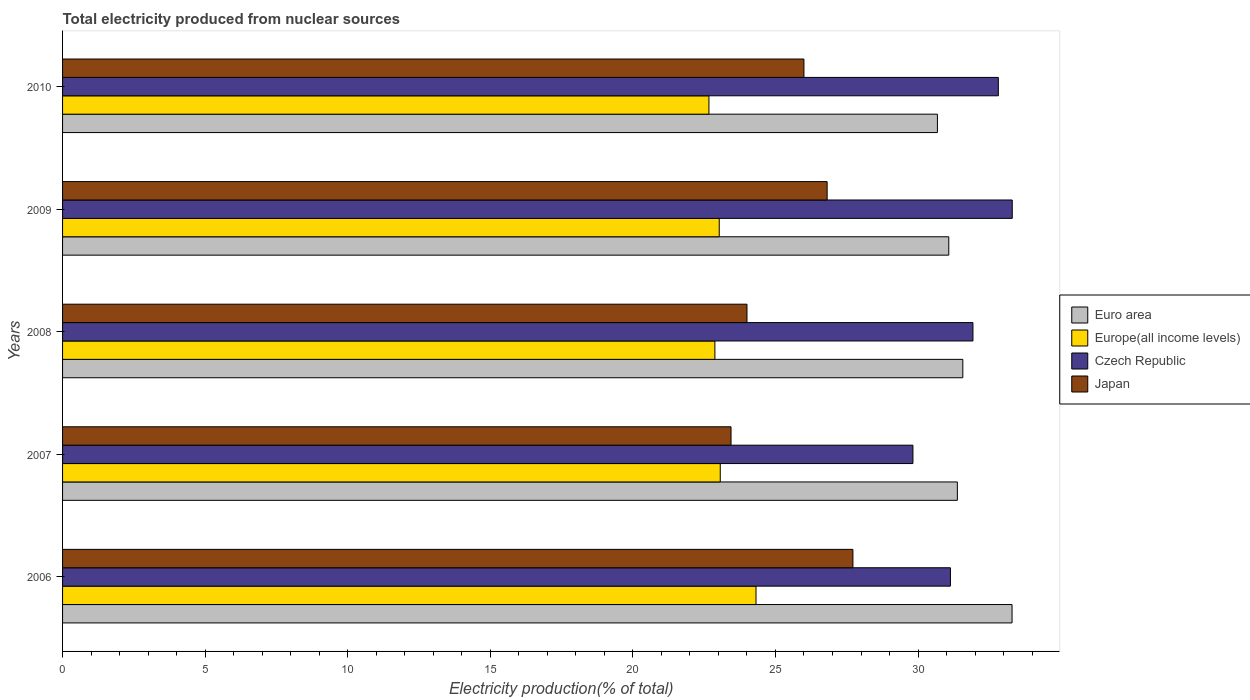Are the number of bars on each tick of the Y-axis equal?
Your answer should be compact. Yes. How many bars are there on the 4th tick from the bottom?
Provide a succinct answer. 4. In how many cases, is the number of bars for a given year not equal to the number of legend labels?
Your answer should be compact. 0. What is the total electricity produced in Europe(all income levels) in 2010?
Make the answer very short. 22.67. Across all years, what is the maximum total electricity produced in Europe(all income levels)?
Ensure brevity in your answer.  24.32. Across all years, what is the minimum total electricity produced in Euro area?
Offer a very short reply. 30.68. In which year was the total electricity produced in Europe(all income levels) maximum?
Provide a succinct answer. 2006. In which year was the total electricity produced in Europe(all income levels) minimum?
Offer a terse response. 2010. What is the total total electricity produced in Euro area in the graph?
Provide a short and direct response. 158. What is the difference between the total electricity produced in Euro area in 2007 and that in 2008?
Make the answer very short. -0.19. What is the difference between the total electricity produced in Japan in 2009 and the total electricity produced in Euro area in 2008?
Ensure brevity in your answer.  -4.76. What is the average total electricity produced in Euro area per year?
Ensure brevity in your answer.  31.6. In the year 2008, what is the difference between the total electricity produced in Europe(all income levels) and total electricity produced in Czech Republic?
Offer a very short reply. -9.05. In how many years, is the total electricity produced in Europe(all income levels) greater than 30 %?
Give a very brief answer. 0. What is the ratio of the total electricity produced in Europe(all income levels) in 2006 to that in 2010?
Your answer should be very brief. 1.07. Is the total electricity produced in Europe(all income levels) in 2007 less than that in 2009?
Provide a short and direct response. No. What is the difference between the highest and the second highest total electricity produced in Czech Republic?
Offer a terse response. 0.49. What is the difference between the highest and the lowest total electricity produced in Japan?
Provide a short and direct response. 4.27. Is the sum of the total electricity produced in Euro area in 2008 and 2009 greater than the maximum total electricity produced in Europe(all income levels) across all years?
Ensure brevity in your answer.  Yes. Is it the case that in every year, the sum of the total electricity produced in Czech Republic and total electricity produced in Japan is greater than the sum of total electricity produced in Europe(all income levels) and total electricity produced in Euro area?
Your answer should be very brief. No. What does the 2nd bar from the top in 2008 represents?
Offer a very short reply. Czech Republic. How many bars are there?
Your response must be concise. 20. Are all the bars in the graph horizontal?
Ensure brevity in your answer.  Yes. How many years are there in the graph?
Your response must be concise. 5. Does the graph contain any zero values?
Your answer should be compact. No. Does the graph contain grids?
Make the answer very short. No. Where does the legend appear in the graph?
Keep it short and to the point. Center right. What is the title of the graph?
Provide a short and direct response. Total electricity produced from nuclear sources. Does "South Asia" appear as one of the legend labels in the graph?
Provide a succinct answer. No. What is the label or title of the Y-axis?
Your answer should be compact. Years. What is the Electricity production(% of total) in Euro area in 2006?
Your answer should be very brief. 33.3. What is the Electricity production(% of total) of Europe(all income levels) in 2006?
Offer a very short reply. 24.32. What is the Electricity production(% of total) of Czech Republic in 2006?
Your answer should be compact. 31.14. What is the Electricity production(% of total) in Japan in 2006?
Your answer should be compact. 27.72. What is the Electricity production(% of total) of Euro area in 2007?
Provide a short and direct response. 31.38. What is the Electricity production(% of total) of Europe(all income levels) in 2007?
Offer a terse response. 23.06. What is the Electricity production(% of total) of Czech Republic in 2007?
Give a very brief answer. 29.82. What is the Electricity production(% of total) of Japan in 2007?
Make the answer very short. 23.44. What is the Electricity production(% of total) of Euro area in 2008?
Make the answer very short. 31.57. What is the Electricity production(% of total) in Europe(all income levels) in 2008?
Keep it short and to the point. 22.88. What is the Electricity production(% of total) in Czech Republic in 2008?
Offer a terse response. 31.93. What is the Electricity production(% of total) in Japan in 2008?
Provide a succinct answer. 24. What is the Electricity production(% of total) in Euro area in 2009?
Offer a terse response. 31.08. What is the Electricity production(% of total) of Europe(all income levels) in 2009?
Ensure brevity in your answer.  23.03. What is the Electricity production(% of total) of Czech Republic in 2009?
Keep it short and to the point. 33.3. What is the Electricity production(% of total) of Japan in 2009?
Provide a short and direct response. 26.81. What is the Electricity production(% of total) in Euro area in 2010?
Provide a short and direct response. 30.68. What is the Electricity production(% of total) of Europe(all income levels) in 2010?
Make the answer very short. 22.67. What is the Electricity production(% of total) of Czech Republic in 2010?
Keep it short and to the point. 32.82. What is the Electricity production(% of total) in Japan in 2010?
Make the answer very short. 26. Across all years, what is the maximum Electricity production(% of total) of Euro area?
Keep it short and to the point. 33.3. Across all years, what is the maximum Electricity production(% of total) in Europe(all income levels)?
Provide a succinct answer. 24.32. Across all years, what is the maximum Electricity production(% of total) in Czech Republic?
Offer a very short reply. 33.3. Across all years, what is the maximum Electricity production(% of total) in Japan?
Ensure brevity in your answer.  27.72. Across all years, what is the minimum Electricity production(% of total) of Euro area?
Provide a short and direct response. 30.68. Across all years, what is the minimum Electricity production(% of total) in Europe(all income levels)?
Your response must be concise. 22.67. Across all years, what is the minimum Electricity production(% of total) of Czech Republic?
Make the answer very short. 29.82. Across all years, what is the minimum Electricity production(% of total) of Japan?
Keep it short and to the point. 23.44. What is the total Electricity production(% of total) of Euro area in the graph?
Your answer should be compact. 158. What is the total Electricity production(% of total) of Europe(all income levels) in the graph?
Offer a terse response. 115.95. What is the total Electricity production(% of total) of Czech Republic in the graph?
Make the answer very short. 159. What is the total Electricity production(% of total) of Japan in the graph?
Offer a very short reply. 127.97. What is the difference between the Electricity production(% of total) of Euro area in 2006 and that in 2007?
Ensure brevity in your answer.  1.92. What is the difference between the Electricity production(% of total) of Europe(all income levels) in 2006 and that in 2007?
Keep it short and to the point. 1.25. What is the difference between the Electricity production(% of total) of Czech Republic in 2006 and that in 2007?
Give a very brief answer. 1.31. What is the difference between the Electricity production(% of total) of Japan in 2006 and that in 2007?
Make the answer very short. 4.27. What is the difference between the Electricity production(% of total) in Euro area in 2006 and that in 2008?
Give a very brief answer. 1.73. What is the difference between the Electricity production(% of total) in Europe(all income levels) in 2006 and that in 2008?
Your answer should be compact. 1.44. What is the difference between the Electricity production(% of total) in Czech Republic in 2006 and that in 2008?
Make the answer very short. -0.79. What is the difference between the Electricity production(% of total) of Japan in 2006 and that in 2008?
Your answer should be very brief. 3.71. What is the difference between the Electricity production(% of total) of Euro area in 2006 and that in 2009?
Your answer should be compact. 2.22. What is the difference between the Electricity production(% of total) in Europe(all income levels) in 2006 and that in 2009?
Ensure brevity in your answer.  1.29. What is the difference between the Electricity production(% of total) of Czech Republic in 2006 and that in 2009?
Provide a succinct answer. -2.17. What is the difference between the Electricity production(% of total) in Japan in 2006 and that in 2009?
Give a very brief answer. 0.9. What is the difference between the Electricity production(% of total) in Euro area in 2006 and that in 2010?
Ensure brevity in your answer.  2.62. What is the difference between the Electricity production(% of total) in Europe(all income levels) in 2006 and that in 2010?
Offer a terse response. 1.65. What is the difference between the Electricity production(% of total) of Czech Republic in 2006 and that in 2010?
Ensure brevity in your answer.  -1.68. What is the difference between the Electricity production(% of total) in Japan in 2006 and that in 2010?
Offer a very short reply. 1.72. What is the difference between the Electricity production(% of total) of Euro area in 2007 and that in 2008?
Keep it short and to the point. -0.19. What is the difference between the Electricity production(% of total) in Europe(all income levels) in 2007 and that in 2008?
Give a very brief answer. 0.19. What is the difference between the Electricity production(% of total) in Czech Republic in 2007 and that in 2008?
Keep it short and to the point. -2.1. What is the difference between the Electricity production(% of total) of Japan in 2007 and that in 2008?
Your answer should be very brief. -0.56. What is the difference between the Electricity production(% of total) in Euro area in 2007 and that in 2009?
Offer a very short reply. 0.3. What is the difference between the Electricity production(% of total) of Europe(all income levels) in 2007 and that in 2009?
Your answer should be compact. 0.04. What is the difference between the Electricity production(% of total) of Czech Republic in 2007 and that in 2009?
Provide a succinct answer. -3.48. What is the difference between the Electricity production(% of total) in Japan in 2007 and that in 2009?
Your answer should be very brief. -3.37. What is the difference between the Electricity production(% of total) in Euro area in 2007 and that in 2010?
Your answer should be very brief. 0.7. What is the difference between the Electricity production(% of total) of Europe(all income levels) in 2007 and that in 2010?
Offer a terse response. 0.4. What is the difference between the Electricity production(% of total) in Czech Republic in 2007 and that in 2010?
Your response must be concise. -2.99. What is the difference between the Electricity production(% of total) in Japan in 2007 and that in 2010?
Your answer should be compact. -2.56. What is the difference between the Electricity production(% of total) of Euro area in 2008 and that in 2009?
Your answer should be compact. 0.49. What is the difference between the Electricity production(% of total) of Europe(all income levels) in 2008 and that in 2009?
Offer a very short reply. -0.15. What is the difference between the Electricity production(% of total) in Czech Republic in 2008 and that in 2009?
Your answer should be very brief. -1.38. What is the difference between the Electricity production(% of total) in Japan in 2008 and that in 2009?
Ensure brevity in your answer.  -2.81. What is the difference between the Electricity production(% of total) in Euro area in 2008 and that in 2010?
Make the answer very short. 0.89. What is the difference between the Electricity production(% of total) in Europe(all income levels) in 2008 and that in 2010?
Provide a succinct answer. 0.21. What is the difference between the Electricity production(% of total) in Czech Republic in 2008 and that in 2010?
Provide a succinct answer. -0.89. What is the difference between the Electricity production(% of total) of Japan in 2008 and that in 2010?
Ensure brevity in your answer.  -2. What is the difference between the Electricity production(% of total) in Euro area in 2009 and that in 2010?
Keep it short and to the point. 0.4. What is the difference between the Electricity production(% of total) of Europe(all income levels) in 2009 and that in 2010?
Provide a succinct answer. 0.36. What is the difference between the Electricity production(% of total) in Czech Republic in 2009 and that in 2010?
Keep it short and to the point. 0.49. What is the difference between the Electricity production(% of total) in Japan in 2009 and that in 2010?
Your answer should be very brief. 0.81. What is the difference between the Electricity production(% of total) in Euro area in 2006 and the Electricity production(% of total) in Europe(all income levels) in 2007?
Provide a short and direct response. 10.23. What is the difference between the Electricity production(% of total) in Euro area in 2006 and the Electricity production(% of total) in Czech Republic in 2007?
Provide a succinct answer. 3.48. What is the difference between the Electricity production(% of total) of Euro area in 2006 and the Electricity production(% of total) of Japan in 2007?
Keep it short and to the point. 9.86. What is the difference between the Electricity production(% of total) in Europe(all income levels) in 2006 and the Electricity production(% of total) in Czech Republic in 2007?
Keep it short and to the point. -5.5. What is the difference between the Electricity production(% of total) of Europe(all income levels) in 2006 and the Electricity production(% of total) of Japan in 2007?
Keep it short and to the point. 0.88. What is the difference between the Electricity production(% of total) in Czech Republic in 2006 and the Electricity production(% of total) in Japan in 2007?
Give a very brief answer. 7.69. What is the difference between the Electricity production(% of total) in Euro area in 2006 and the Electricity production(% of total) in Europe(all income levels) in 2008?
Keep it short and to the point. 10.42. What is the difference between the Electricity production(% of total) in Euro area in 2006 and the Electricity production(% of total) in Czech Republic in 2008?
Provide a short and direct response. 1.37. What is the difference between the Electricity production(% of total) in Euro area in 2006 and the Electricity production(% of total) in Japan in 2008?
Your answer should be very brief. 9.3. What is the difference between the Electricity production(% of total) of Europe(all income levels) in 2006 and the Electricity production(% of total) of Czech Republic in 2008?
Offer a very short reply. -7.61. What is the difference between the Electricity production(% of total) in Europe(all income levels) in 2006 and the Electricity production(% of total) in Japan in 2008?
Give a very brief answer. 0.32. What is the difference between the Electricity production(% of total) in Czech Republic in 2006 and the Electricity production(% of total) in Japan in 2008?
Make the answer very short. 7.13. What is the difference between the Electricity production(% of total) of Euro area in 2006 and the Electricity production(% of total) of Europe(all income levels) in 2009?
Provide a succinct answer. 10.27. What is the difference between the Electricity production(% of total) of Euro area in 2006 and the Electricity production(% of total) of Czech Republic in 2009?
Your answer should be compact. -0.01. What is the difference between the Electricity production(% of total) in Euro area in 2006 and the Electricity production(% of total) in Japan in 2009?
Provide a short and direct response. 6.48. What is the difference between the Electricity production(% of total) in Europe(all income levels) in 2006 and the Electricity production(% of total) in Czech Republic in 2009?
Your answer should be compact. -8.99. What is the difference between the Electricity production(% of total) of Europe(all income levels) in 2006 and the Electricity production(% of total) of Japan in 2009?
Provide a short and direct response. -2.49. What is the difference between the Electricity production(% of total) in Czech Republic in 2006 and the Electricity production(% of total) in Japan in 2009?
Ensure brevity in your answer.  4.32. What is the difference between the Electricity production(% of total) in Euro area in 2006 and the Electricity production(% of total) in Europe(all income levels) in 2010?
Make the answer very short. 10.63. What is the difference between the Electricity production(% of total) in Euro area in 2006 and the Electricity production(% of total) in Czech Republic in 2010?
Give a very brief answer. 0.48. What is the difference between the Electricity production(% of total) of Euro area in 2006 and the Electricity production(% of total) of Japan in 2010?
Your answer should be very brief. 7.3. What is the difference between the Electricity production(% of total) in Europe(all income levels) in 2006 and the Electricity production(% of total) in Czech Republic in 2010?
Give a very brief answer. -8.5. What is the difference between the Electricity production(% of total) in Europe(all income levels) in 2006 and the Electricity production(% of total) in Japan in 2010?
Provide a short and direct response. -1.68. What is the difference between the Electricity production(% of total) of Czech Republic in 2006 and the Electricity production(% of total) of Japan in 2010?
Give a very brief answer. 5.14. What is the difference between the Electricity production(% of total) in Euro area in 2007 and the Electricity production(% of total) in Europe(all income levels) in 2008?
Your response must be concise. 8.5. What is the difference between the Electricity production(% of total) in Euro area in 2007 and the Electricity production(% of total) in Czech Republic in 2008?
Ensure brevity in your answer.  -0.55. What is the difference between the Electricity production(% of total) of Euro area in 2007 and the Electricity production(% of total) of Japan in 2008?
Keep it short and to the point. 7.38. What is the difference between the Electricity production(% of total) of Europe(all income levels) in 2007 and the Electricity production(% of total) of Czech Republic in 2008?
Provide a short and direct response. -8.86. What is the difference between the Electricity production(% of total) of Europe(all income levels) in 2007 and the Electricity production(% of total) of Japan in 2008?
Provide a short and direct response. -0.94. What is the difference between the Electricity production(% of total) of Czech Republic in 2007 and the Electricity production(% of total) of Japan in 2008?
Offer a terse response. 5.82. What is the difference between the Electricity production(% of total) in Euro area in 2007 and the Electricity production(% of total) in Europe(all income levels) in 2009?
Offer a very short reply. 8.35. What is the difference between the Electricity production(% of total) in Euro area in 2007 and the Electricity production(% of total) in Czech Republic in 2009?
Make the answer very short. -1.93. What is the difference between the Electricity production(% of total) of Euro area in 2007 and the Electricity production(% of total) of Japan in 2009?
Give a very brief answer. 4.57. What is the difference between the Electricity production(% of total) of Europe(all income levels) in 2007 and the Electricity production(% of total) of Czech Republic in 2009?
Keep it short and to the point. -10.24. What is the difference between the Electricity production(% of total) of Europe(all income levels) in 2007 and the Electricity production(% of total) of Japan in 2009?
Offer a very short reply. -3.75. What is the difference between the Electricity production(% of total) of Czech Republic in 2007 and the Electricity production(% of total) of Japan in 2009?
Provide a succinct answer. 3.01. What is the difference between the Electricity production(% of total) of Euro area in 2007 and the Electricity production(% of total) of Europe(all income levels) in 2010?
Make the answer very short. 8.71. What is the difference between the Electricity production(% of total) of Euro area in 2007 and the Electricity production(% of total) of Czech Republic in 2010?
Ensure brevity in your answer.  -1.44. What is the difference between the Electricity production(% of total) of Euro area in 2007 and the Electricity production(% of total) of Japan in 2010?
Your answer should be very brief. 5.38. What is the difference between the Electricity production(% of total) in Europe(all income levels) in 2007 and the Electricity production(% of total) in Czech Republic in 2010?
Offer a terse response. -9.75. What is the difference between the Electricity production(% of total) in Europe(all income levels) in 2007 and the Electricity production(% of total) in Japan in 2010?
Offer a terse response. -2.93. What is the difference between the Electricity production(% of total) of Czech Republic in 2007 and the Electricity production(% of total) of Japan in 2010?
Provide a succinct answer. 3.82. What is the difference between the Electricity production(% of total) of Euro area in 2008 and the Electricity production(% of total) of Europe(all income levels) in 2009?
Keep it short and to the point. 8.54. What is the difference between the Electricity production(% of total) of Euro area in 2008 and the Electricity production(% of total) of Czech Republic in 2009?
Ensure brevity in your answer.  -1.73. What is the difference between the Electricity production(% of total) in Euro area in 2008 and the Electricity production(% of total) in Japan in 2009?
Offer a terse response. 4.76. What is the difference between the Electricity production(% of total) in Europe(all income levels) in 2008 and the Electricity production(% of total) in Czech Republic in 2009?
Your answer should be compact. -10.43. What is the difference between the Electricity production(% of total) in Europe(all income levels) in 2008 and the Electricity production(% of total) in Japan in 2009?
Your answer should be very brief. -3.94. What is the difference between the Electricity production(% of total) in Czech Republic in 2008 and the Electricity production(% of total) in Japan in 2009?
Your answer should be compact. 5.11. What is the difference between the Electricity production(% of total) in Euro area in 2008 and the Electricity production(% of total) in Europe(all income levels) in 2010?
Your answer should be compact. 8.9. What is the difference between the Electricity production(% of total) of Euro area in 2008 and the Electricity production(% of total) of Czech Republic in 2010?
Offer a terse response. -1.25. What is the difference between the Electricity production(% of total) of Euro area in 2008 and the Electricity production(% of total) of Japan in 2010?
Make the answer very short. 5.57. What is the difference between the Electricity production(% of total) of Europe(all income levels) in 2008 and the Electricity production(% of total) of Czech Republic in 2010?
Your answer should be very brief. -9.94. What is the difference between the Electricity production(% of total) of Europe(all income levels) in 2008 and the Electricity production(% of total) of Japan in 2010?
Make the answer very short. -3.12. What is the difference between the Electricity production(% of total) of Czech Republic in 2008 and the Electricity production(% of total) of Japan in 2010?
Your response must be concise. 5.93. What is the difference between the Electricity production(% of total) in Euro area in 2009 and the Electricity production(% of total) in Europe(all income levels) in 2010?
Your answer should be compact. 8.41. What is the difference between the Electricity production(% of total) of Euro area in 2009 and the Electricity production(% of total) of Czech Republic in 2010?
Keep it short and to the point. -1.74. What is the difference between the Electricity production(% of total) in Euro area in 2009 and the Electricity production(% of total) in Japan in 2010?
Your answer should be compact. 5.08. What is the difference between the Electricity production(% of total) in Europe(all income levels) in 2009 and the Electricity production(% of total) in Czech Republic in 2010?
Keep it short and to the point. -9.79. What is the difference between the Electricity production(% of total) of Europe(all income levels) in 2009 and the Electricity production(% of total) of Japan in 2010?
Make the answer very short. -2.97. What is the difference between the Electricity production(% of total) of Czech Republic in 2009 and the Electricity production(% of total) of Japan in 2010?
Offer a very short reply. 7.31. What is the average Electricity production(% of total) in Euro area per year?
Provide a short and direct response. 31.6. What is the average Electricity production(% of total) of Europe(all income levels) per year?
Your answer should be compact. 23.19. What is the average Electricity production(% of total) of Czech Republic per year?
Your response must be concise. 31.8. What is the average Electricity production(% of total) of Japan per year?
Offer a terse response. 25.59. In the year 2006, what is the difference between the Electricity production(% of total) in Euro area and Electricity production(% of total) in Europe(all income levels)?
Your answer should be compact. 8.98. In the year 2006, what is the difference between the Electricity production(% of total) in Euro area and Electricity production(% of total) in Czech Republic?
Your response must be concise. 2.16. In the year 2006, what is the difference between the Electricity production(% of total) of Euro area and Electricity production(% of total) of Japan?
Make the answer very short. 5.58. In the year 2006, what is the difference between the Electricity production(% of total) in Europe(all income levels) and Electricity production(% of total) in Czech Republic?
Your response must be concise. -6.82. In the year 2006, what is the difference between the Electricity production(% of total) of Europe(all income levels) and Electricity production(% of total) of Japan?
Your response must be concise. -3.4. In the year 2006, what is the difference between the Electricity production(% of total) in Czech Republic and Electricity production(% of total) in Japan?
Ensure brevity in your answer.  3.42. In the year 2007, what is the difference between the Electricity production(% of total) of Euro area and Electricity production(% of total) of Europe(all income levels)?
Ensure brevity in your answer.  8.31. In the year 2007, what is the difference between the Electricity production(% of total) of Euro area and Electricity production(% of total) of Czech Republic?
Offer a terse response. 1.56. In the year 2007, what is the difference between the Electricity production(% of total) of Euro area and Electricity production(% of total) of Japan?
Offer a very short reply. 7.94. In the year 2007, what is the difference between the Electricity production(% of total) in Europe(all income levels) and Electricity production(% of total) in Czech Republic?
Your answer should be compact. -6.76. In the year 2007, what is the difference between the Electricity production(% of total) in Europe(all income levels) and Electricity production(% of total) in Japan?
Ensure brevity in your answer.  -0.38. In the year 2007, what is the difference between the Electricity production(% of total) in Czech Republic and Electricity production(% of total) in Japan?
Give a very brief answer. 6.38. In the year 2008, what is the difference between the Electricity production(% of total) of Euro area and Electricity production(% of total) of Europe(all income levels)?
Give a very brief answer. 8.69. In the year 2008, what is the difference between the Electricity production(% of total) in Euro area and Electricity production(% of total) in Czech Republic?
Offer a terse response. -0.36. In the year 2008, what is the difference between the Electricity production(% of total) of Euro area and Electricity production(% of total) of Japan?
Your answer should be compact. 7.57. In the year 2008, what is the difference between the Electricity production(% of total) of Europe(all income levels) and Electricity production(% of total) of Czech Republic?
Keep it short and to the point. -9.05. In the year 2008, what is the difference between the Electricity production(% of total) in Europe(all income levels) and Electricity production(% of total) in Japan?
Your answer should be very brief. -1.13. In the year 2008, what is the difference between the Electricity production(% of total) of Czech Republic and Electricity production(% of total) of Japan?
Offer a terse response. 7.92. In the year 2009, what is the difference between the Electricity production(% of total) of Euro area and Electricity production(% of total) of Europe(all income levels)?
Your answer should be compact. 8.05. In the year 2009, what is the difference between the Electricity production(% of total) in Euro area and Electricity production(% of total) in Czech Republic?
Offer a terse response. -2.23. In the year 2009, what is the difference between the Electricity production(% of total) in Euro area and Electricity production(% of total) in Japan?
Give a very brief answer. 4.27. In the year 2009, what is the difference between the Electricity production(% of total) of Europe(all income levels) and Electricity production(% of total) of Czech Republic?
Make the answer very short. -10.28. In the year 2009, what is the difference between the Electricity production(% of total) in Europe(all income levels) and Electricity production(% of total) in Japan?
Provide a short and direct response. -3.78. In the year 2009, what is the difference between the Electricity production(% of total) of Czech Republic and Electricity production(% of total) of Japan?
Ensure brevity in your answer.  6.49. In the year 2010, what is the difference between the Electricity production(% of total) of Euro area and Electricity production(% of total) of Europe(all income levels)?
Keep it short and to the point. 8.01. In the year 2010, what is the difference between the Electricity production(% of total) in Euro area and Electricity production(% of total) in Czech Republic?
Make the answer very short. -2.14. In the year 2010, what is the difference between the Electricity production(% of total) of Euro area and Electricity production(% of total) of Japan?
Give a very brief answer. 4.68. In the year 2010, what is the difference between the Electricity production(% of total) of Europe(all income levels) and Electricity production(% of total) of Czech Republic?
Your answer should be compact. -10.15. In the year 2010, what is the difference between the Electricity production(% of total) of Europe(all income levels) and Electricity production(% of total) of Japan?
Make the answer very short. -3.33. In the year 2010, what is the difference between the Electricity production(% of total) in Czech Republic and Electricity production(% of total) in Japan?
Provide a short and direct response. 6.82. What is the ratio of the Electricity production(% of total) of Euro area in 2006 to that in 2007?
Provide a succinct answer. 1.06. What is the ratio of the Electricity production(% of total) of Europe(all income levels) in 2006 to that in 2007?
Your response must be concise. 1.05. What is the ratio of the Electricity production(% of total) of Czech Republic in 2006 to that in 2007?
Your answer should be very brief. 1.04. What is the ratio of the Electricity production(% of total) of Japan in 2006 to that in 2007?
Offer a very short reply. 1.18. What is the ratio of the Electricity production(% of total) in Euro area in 2006 to that in 2008?
Your answer should be very brief. 1.05. What is the ratio of the Electricity production(% of total) of Europe(all income levels) in 2006 to that in 2008?
Make the answer very short. 1.06. What is the ratio of the Electricity production(% of total) in Czech Republic in 2006 to that in 2008?
Make the answer very short. 0.98. What is the ratio of the Electricity production(% of total) of Japan in 2006 to that in 2008?
Give a very brief answer. 1.15. What is the ratio of the Electricity production(% of total) of Euro area in 2006 to that in 2009?
Keep it short and to the point. 1.07. What is the ratio of the Electricity production(% of total) of Europe(all income levels) in 2006 to that in 2009?
Your answer should be very brief. 1.06. What is the ratio of the Electricity production(% of total) of Czech Republic in 2006 to that in 2009?
Provide a succinct answer. 0.93. What is the ratio of the Electricity production(% of total) of Japan in 2006 to that in 2009?
Your answer should be very brief. 1.03. What is the ratio of the Electricity production(% of total) of Euro area in 2006 to that in 2010?
Keep it short and to the point. 1.09. What is the ratio of the Electricity production(% of total) of Europe(all income levels) in 2006 to that in 2010?
Provide a succinct answer. 1.07. What is the ratio of the Electricity production(% of total) of Czech Republic in 2006 to that in 2010?
Offer a terse response. 0.95. What is the ratio of the Electricity production(% of total) of Japan in 2006 to that in 2010?
Offer a very short reply. 1.07. What is the ratio of the Electricity production(% of total) in Euro area in 2007 to that in 2008?
Offer a terse response. 0.99. What is the ratio of the Electricity production(% of total) in Europe(all income levels) in 2007 to that in 2008?
Make the answer very short. 1.01. What is the ratio of the Electricity production(% of total) of Czech Republic in 2007 to that in 2008?
Provide a succinct answer. 0.93. What is the ratio of the Electricity production(% of total) in Japan in 2007 to that in 2008?
Give a very brief answer. 0.98. What is the ratio of the Electricity production(% of total) in Euro area in 2007 to that in 2009?
Ensure brevity in your answer.  1.01. What is the ratio of the Electricity production(% of total) in Czech Republic in 2007 to that in 2009?
Your response must be concise. 0.9. What is the ratio of the Electricity production(% of total) in Japan in 2007 to that in 2009?
Make the answer very short. 0.87. What is the ratio of the Electricity production(% of total) in Euro area in 2007 to that in 2010?
Ensure brevity in your answer.  1.02. What is the ratio of the Electricity production(% of total) of Europe(all income levels) in 2007 to that in 2010?
Keep it short and to the point. 1.02. What is the ratio of the Electricity production(% of total) of Czech Republic in 2007 to that in 2010?
Ensure brevity in your answer.  0.91. What is the ratio of the Electricity production(% of total) of Japan in 2007 to that in 2010?
Make the answer very short. 0.9. What is the ratio of the Electricity production(% of total) in Euro area in 2008 to that in 2009?
Give a very brief answer. 1.02. What is the ratio of the Electricity production(% of total) of Europe(all income levels) in 2008 to that in 2009?
Keep it short and to the point. 0.99. What is the ratio of the Electricity production(% of total) in Czech Republic in 2008 to that in 2009?
Your answer should be very brief. 0.96. What is the ratio of the Electricity production(% of total) in Japan in 2008 to that in 2009?
Offer a very short reply. 0.9. What is the ratio of the Electricity production(% of total) in Euro area in 2008 to that in 2010?
Provide a succinct answer. 1.03. What is the ratio of the Electricity production(% of total) in Europe(all income levels) in 2008 to that in 2010?
Offer a very short reply. 1.01. What is the ratio of the Electricity production(% of total) of Czech Republic in 2008 to that in 2010?
Make the answer very short. 0.97. What is the ratio of the Electricity production(% of total) in Japan in 2008 to that in 2010?
Provide a short and direct response. 0.92. What is the ratio of the Electricity production(% of total) in Euro area in 2009 to that in 2010?
Give a very brief answer. 1.01. What is the ratio of the Electricity production(% of total) in Europe(all income levels) in 2009 to that in 2010?
Give a very brief answer. 1.02. What is the ratio of the Electricity production(% of total) in Czech Republic in 2009 to that in 2010?
Your answer should be compact. 1.01. What is the ratio of the Electricity production(% of total) of Japan in 2009 to that in 2010?
Ensure brevity in your answer.  1.03. What is the difference between the highest and the second highest Electricity production(% of total) of Euro area?
Your answer should be very brief. 1.73. What is the difference between the highest and the second highest Electricity production(% of total) of Europe(all income levels)?
Provide a short and direct response. 1.25. What is the difference between the highest and the second highest Electricity production(% of total) in Czech Republic?
Provide a short and direct response. 0.49. What is the difference between the highest and the second highest Electricity production(% of total) in Japan?
Offer a terse response. 0.9. What is the difference between the highest and the lowest Electricity production(% of total) in Euro area?
Your answer should be very brief. 2.62. What is the difference between the highest and the lowest Electricity production(% of total) in Europe(all income levels)?
Give a very brief answer. 1.65. What is the difference between the highest and the lowest Electricity production(% of total) in Czech Republic?
Give a very brief answer. 3.48. What is the difference between the highest and the lowest Electricity production(% of total) in Japan?
Offer a very short reply. 4.27. 